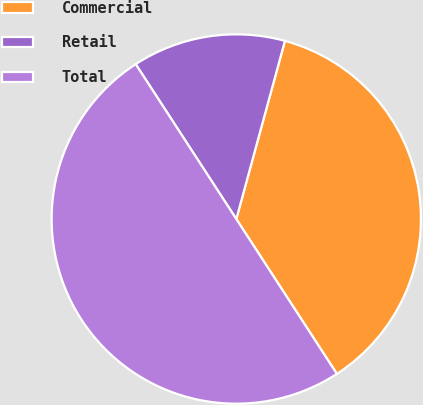Convert chart to OTSL. <chart><loc_0><loc_0><loc_500><loc_500><pie_chart><fcel>Commercial<fcel>Retail<fcel>Total<nl><fcel>36.59%<fcel>13.41%<fcel>50.0%<nl></chart> 